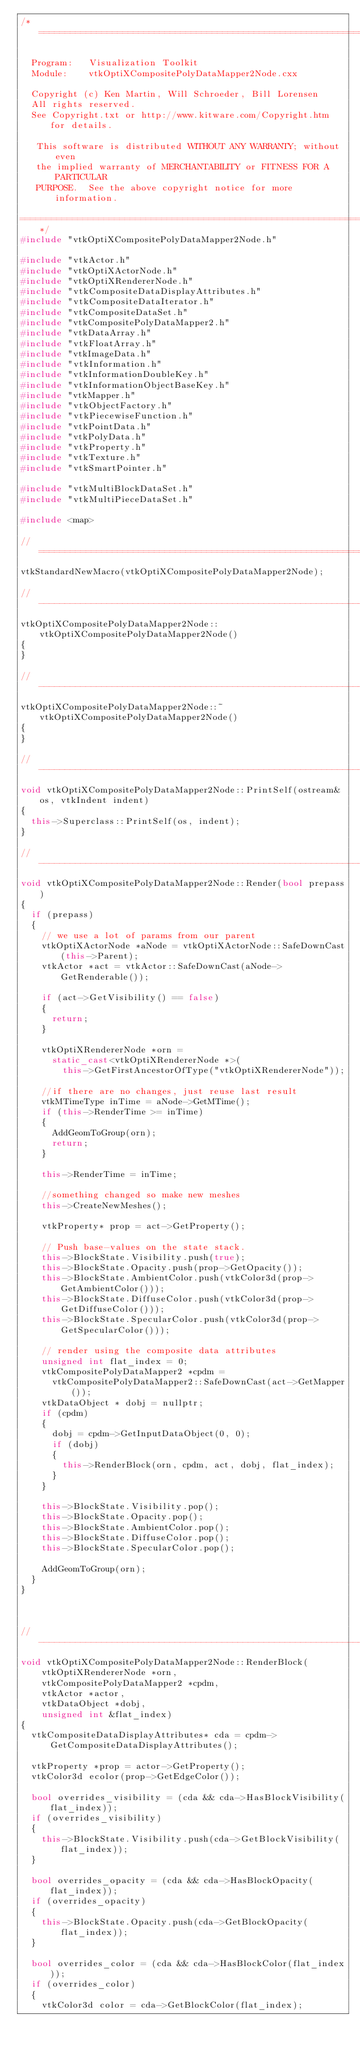<code> <loc_0><loc_0><loc_500><loc_500><_C++_>/*=========================================================================

  Program:   Visualization Toolkit
  Module:    vtkOptiXCompositePolyDataMapper2Node.cxx

  Copyright (c) Ken Martin, Will Schroeder, Bill Lorensen
  All rights reserved.
  See Copyright.txt or http://www.kitware.com/Copyright.htm for details.

   This software is distributed WITHOUT ANY WARRANTY; without even
   the implied warranty of MERCHANTABILITY or FITNESS FOR A PARTICULAR
   PURPOSE.  See the above copyright notice for more information.

=========================================================================*/
#include "vtkOptiXCompositePolyDataMapper2Node.h"

#include "vtkActor.h"
#include "vtkOptiXActorNode.h"
#include "vtkOptiXRendererNode.h"
#include "vtkCompositeDataDisplayAttributes.h"
#include "vtkCompositeDataIterator.h"
#include "vtkCompositeDataSet.h"
#include "vtkCompositePolyDataMapper2.h"
#include "vtkDataArray.h"
#include "vtkFloatArray.h"
#include "vtkImageData.h"
#include "vtkInformation.h"
#include "vtkInformationDoubleKey.h"
#include "vtkInformationObjectBaseKey.h"
#include "vtkMapper.h"
#include "vtkObjectFactory.h"
#include "vtkPiecewiseFunction.h"
#include "vtkPointData.h"
#include "vtkPolyData.h"
#include "vtkProperty.h"
#include "vtkTexture.h"
#include "vtkSmartPointer.h"

#include "vtkMultiBlockDataSet.h"
#include "vtkMultiPieceDataSet.h"

#include <map>

//============================================================================
vtkStandardNewMacro(vtkOptiXCompositePolyDataMapper2Node);

//------------------------------------------------------------------------------
vtkOptiXCompositePolyDataMapper2Node::vtkOptiXCompositePolyDataMapper2Node()
{
}

//------------------------------------------------------------------------------
vtkOptiXCompositePolyDataMapper2Node::~vtkOptiXCompositePolyDataMapper2Node()
{
}

//------------------------------------------------------------------------------
void vtkOptiXCompositePolyDataMapper2Node::PrintSelf(ostream& os, vtkIndent indent)
{
  this->Superclass::PrintSelf(os, indent);
}

//------------------------------------------------------------------------------
void vtkOptiXCompositePolyDataMapper2Node::Render(bool prepass)
{
  if (prepass)
  {
    // we use a lot of params from our parent
    vtkOptiXActorNode *aNode = vtkOptiXActorNode::SafeDownCast(this->Parent);
    vtkActor *act = vtkActor::SafeDownCast(aNode->GetRenderable());

    if (act->GetVisibility() == false)
    {
      return;
    }

    vtkOptiXRendererNode *orn =
      static_cast<vtkOptiXRendererNode *>(
        this->GetFirstAncestorOfType("vtkOptiXRendererNode"));

    //if there are no changes, just reuse last result
    vtkMTimeType inTime = aNode->GetMTime();
    if (this->RenderTime >= inTime)
    {
      AddGeomToGroup(orn);
      return;
    }

    this->RenderTime = inTime;

    //something changed so make new meshes
    this->CreateNewMeshes();

    vtkProperty* prop = act->GetProperty();

    // Push base-values on the state stack.
    this->BlockState.Visibility.push(true);
    this->BlockState.Opacity.push(prop->GetOpacity());
    this->BlockState.AmbientColor.push(vtkColor3d(prop->GetAmbientColor()));
    this->BlockState.DiffuseColor.push(vtkColor3d(prop->GetDiffuseColor()));
    this->BlockState.SpecularColor.push(vtkColor3d(prop->GetSpecularColor()));

    // render using the composite data attributes
    unsigned int flat_index = 0;
    vtkCompositePolyDataMapper2 *cpdm =
      vtkCompositePolyDataMapper2::SafeDownCast(act->GetMapper());
    vtkDataObject * dobj = nullptr;
    if (cpdm)
    {
      dobj = cpdm->GetInputDataObject(0, 0);
      if (dobj)
      {
        this->RenderBlock(orn, cpdm, act, dobj, flat_index);
      }
    }

    this->BlockState.Visibility.pop();
    this->BlockState.Opacity.pop();
    this->BlockState.AmbientColor.pop();
    this->BlockState.DiffuseColor.pop();
    this->BlockState.SpecularColor.pop();

    AddGeomToGroup(orn);
  }
}



//------------------------------------------------------------------------------
void vtkOptiXCompositePolyDataMapper2Node::RenderBlock(
    vtkOptiXRendererNode *orn,
    vtkCompositePolyDataMapper2 *cpdm,
    vtkActor *actor,
    vtkDataObject *dobj,
    unsigned int &flat_index)
{
  vtkCompositeDataDisplayAttributes* cda = cpdm->GetCompositeDataDisplayAttributes();

  vtkProperty *prop = actor->GetProperty();
  vtkColor3d ecolor(prop->GetEdgeColor());

  bool overrides_visibility = (cda && cda->HasBlockVisibility(flat_index));
  if (overrides_visibility)
  {
    this->BlockState.Visibility.push(cda->GetBlockVisibility(flat_index));
  }

  bool overrides_opacity = (cda && cda->HasBlockOpacity(flat_index));
  if (overrides_opacity)
  {
    this->BlockState.Opacity.push(cda->GetBlockOpacity(flat_index));
  }

  bool overrides_color = (cda && cda->HasBlockColor(flat_index));
  if (overrides_color)
  {
    vtkColor3d color = cda->GetBlockColor(flat_index);</code> 